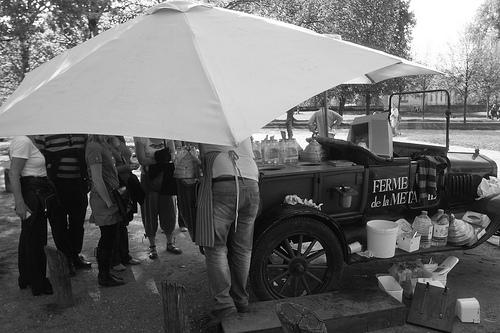Question: how many cars can you see?
Choices:
A. One.
B. Two.
C. Three.
D. None.
Answer with the letter. Answer: A Question: where are the people relevant to the umbrellas?
Choices:
A. Beneath them.
B. Underneath them.
C. Beside them.
D. In front of them.
Answer with the letter. Answer: B Question: where is the cardboard box?
Choices:
A. On a chair.
B. On a bed.
C. On a sofa.
D. In the car.
Answer with the letter. Answer: D Question: what kind of pants is the vendor wearing?
Choices:
A. Slacks.
B. Khakis.
C. Jeans.
D. Sweats.
Answer with the letter. Answer: C Question: what letter does the name on the car begin with?
Choices:
A. F.
B. K.
C. P.
D. J.
Answer with the letter. Answer: A Question: what color is the umbrellas?
Choices:
A. Black.
B. White.
C. Grey.
D. Red.
Answer with the letter. Answer: B 